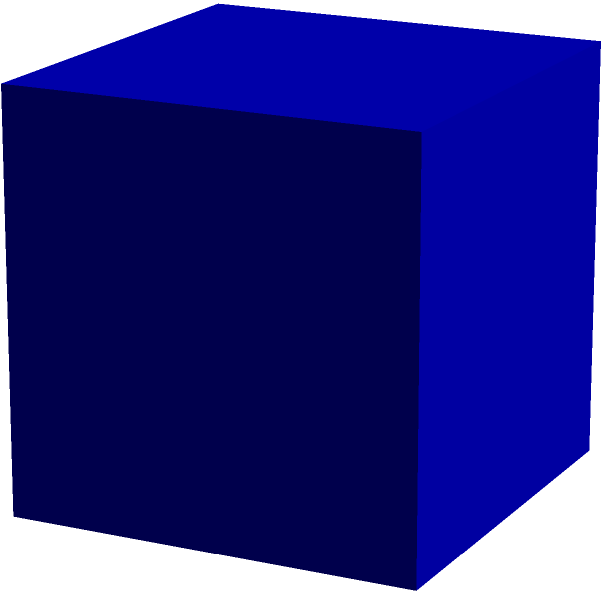Look at the image of a cube. Can you count and tell me how many faces, edges, and vertices this shape has in total? Let's break this down step-by-step:

1. Faces:
   - A cube has 6 square faces (top, bottom, front, back, left, and right).
   - Count each flat surface: 1 + 1 + 1 + 1 + 1 + 1 = 6 faces

2. Edges:
   - Each face has 4 edges.
   - But each edge is shared by 2 faces.
   - So, total edges = (6 faces × 4 edges per face) ÷ 2 = 24 ÷ 2 = 12 edges

3. Vertices:
   - Count the corners of the cube.
   - There are 4 corners on the top and 4 on the bottom.
   - Total vertices = 4 + 4 = 8 vertices

Therefore, a cube has 6 faces, 12 edges, and 8 vertices.
Answer: 6 faces, 12 edges, 8 vertices 